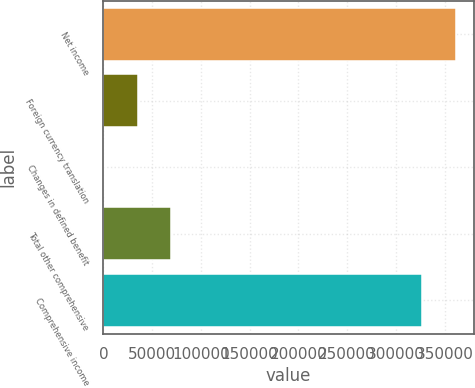Convert chart. <chart><loc_0><loc_0><loc_500><loc_500><bar_chart><fcel>Net income<fcel>Foreign currency translation<fcel>Changes in defined benefit<fcel>Total other comprehensive<fcel>Comprehensive income<nl><fcel>361780<fcel>35142<fcel>627<fcel>69657<fcel>327265<nl></chart> 